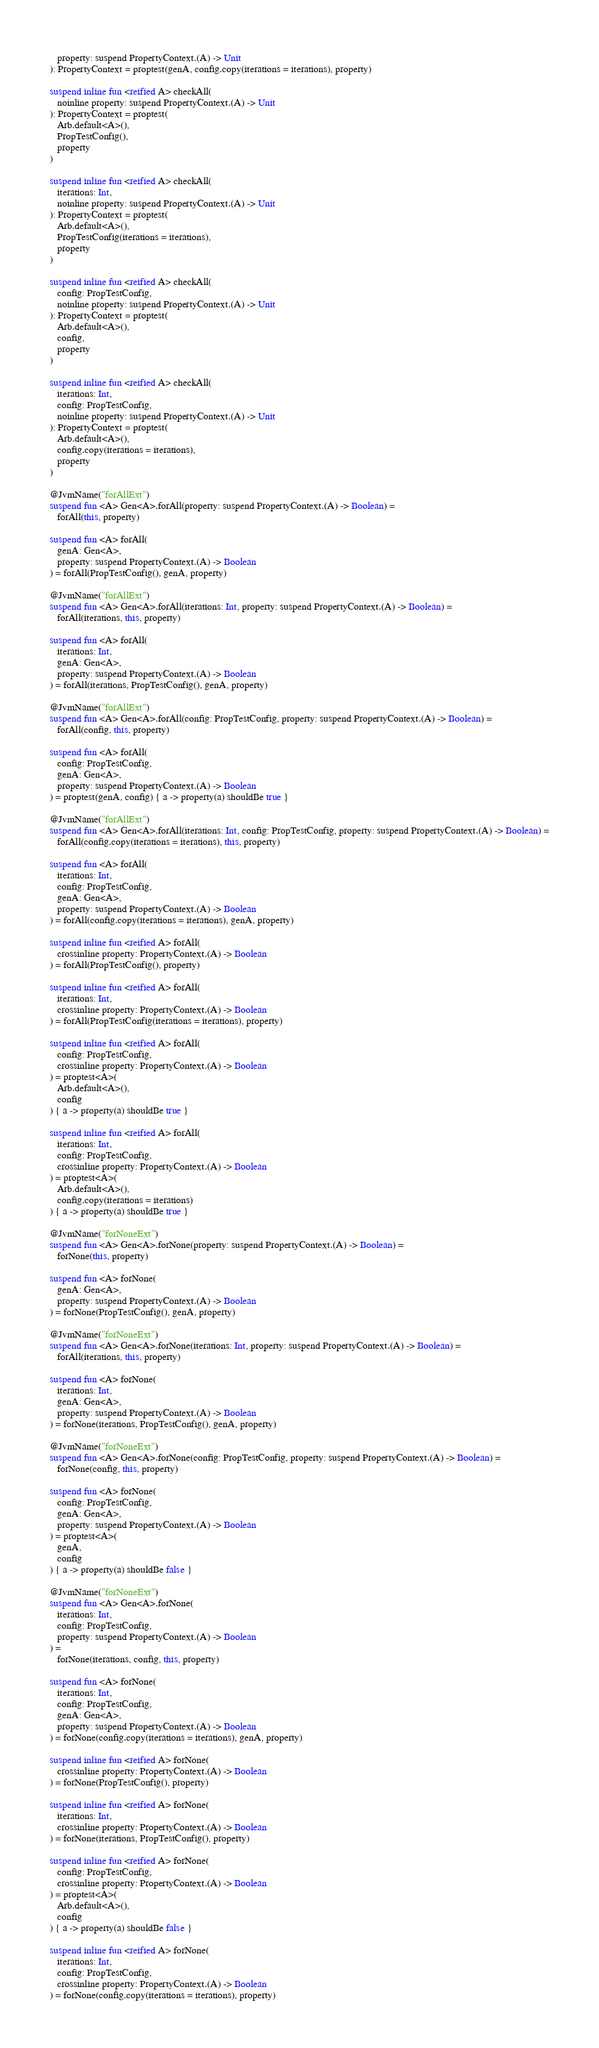<code> <loc_0><loc_0><loc_500><loc_500><_Kotlin_>   property: suspend PropertyContext.(A) -> Unit
): PropertyContext = proptest(genA, config.copy(iterations = iterations), property)

suspend inline fun <reified A> checkAll(
   noinline property: suspend PropertyContext.(A) -> Unit
): PropertyContext = proptest(
   Arb.default<A>(),
   PropTestConfig(),
   property
)

suspend inline fun <reified A> checkAll(
   iterations: Int,
   noinline property: suspend PropertyContext.(A) -> Unit
): PropertyContext = proptest(
   Arb.default<A>(),
   PropTestConfig(iterations = iterations),
   property
)

suspend inline fun <reified A> checkAll(
   config: PropTestConfig,
   noinline property: suspend PropertyContext.(A) -> Unit
): PropertyContext = proptest(
   Arb.default<A>(),
   config,
   property
)

suspend inline fun <reified A> checkAll(
   iterations: Int,
   config: PropTestConfig,
   noinline property: suspend PropertyContext.(A) -> Unit
): PropertyContext = proptest(
   Arb.default<A>(),
   config.copy(iterations = iterations),
   property
)

@JvmName("forAllExt")
suspend fun <A> Gen<A>.forAll(property: suspend PropertyContext.(A) -> Boolean) =
   forAll(this, property)

suspend fun <A> forAll(
   genA: Gen<A>,
   property: suspend PropertyContext.(A) -> Boolean
) = forAll(PropTestConfig(), genA, property)

@JvmName("forAllExt")
suspend fun <A> Gen<A>.forAll(iterations: Int, property: suspend PropertyContext.(A) -> Boolean) =
   forAll(iterations, this, property)

suspend fun <A> forAll(
   iterations: Int,
   genA: Gen<A>,
   property: suspend PropertyContext.(A) -> Boolean
) = forAll(iterations, PropTestConfig(), genA, property)

@JvmName("forAllExt")
suspend fun <A> Gen<A>.forAll(config: PropTestConfig, property: suspend PropertyContext.(A) -> Boolean) =
   forAll(config, this, property)

suspend fun <A> forAll(
   config: PropTestConfig,
   genA: Gen<A>,
   property: suspend PropertyContext.(A) -> Boolean
) = proptest(genA, config) { a -> property(a) shouldBe true }

@JvmName("forAllExt")
suspend fun <A> Gen<A>.forAll(iterations: Int, config: PropTestConfig, property: suspend PropertyContext.(A) -> Boolean) =
   forAll(config.copy(iterations = iterations), this, property)

suspend fun <A> forAll(
   iterations: Int,
   config: PropTestConfig,
   genA: Gen<A>,
   property: suspend PropertyContext.(A) -> Boolean
) = forAll(config.copy(iterations = iterations), genA, property)

suspend inline fun <reified A> forAll(
   crossinline property: PropertyContext.(A) -> Boolean
) = forAll(PropTestConfig(), property)

suspend inline fun <reified A> forAll(
   iterations: Int,
   crossinline property: PropertyContext.(A) -> Boolean
) = forAll(PropTestConfig(iterations = iterations), property)

suspend inline fun <reified A> forAll(
   config: PropTestConfig,
   crossinline property: PropertyContext.(A) -> Boolean
) = proptest<A>(
   Arb.default<A>(),
   config
) { a -> property(a) shouldBe true }

suspend inline fun <reified A> forAll(
   iterations: Int,
   config: PropTestConfig,
   crossinline property: PropertyContext.(A) -> Boolean
) = proptest<A>(
   Arb.default<A>(),
   config.copy(iterations = iterations)
) { a -> property(a) shouldBe true }

@JvmName("forNoneExt")
suspend fun <A> Gen<A>.forNone(property: suspend PropertyContext.(A) -> Boolean) =
   forNone(this, property)

suspend fun <A> forNone(
   genA: Gen<A>,
   property: suspend PropertyContext.(A) -> Boolean
) = forNone(PropTestConfig(), genA, property)

@JvmName("forNoneExt")
suspend fun <A> Gen<A>.forNone(iterations: Int, property: suspend PropertyContext.(A) -> Boolean) =
   forAll(iterations, this, property)

suspend fun <A> forNone(
   iterations: Int,
   genA: Gen<A>,
   property: suspend PropertyContext.(A) -> Boolean
) = forNone(iterations, PropTestConfig(), genA, property)

@JvmName("forNoneExt")
suspend fun <A> Gen<A>.forNone(config: PropTestConfig, property: suspend PropertyContext.(A) -> Boolean) =
   forNone(config, this, property)

suspend fun <A> forNone(
   config: PropTestConfig,
   genA: Gen<A>,
   property: suspend PropertyContext.(A) -> Boolean
) = proptest<A>(
   genA,
   config
) { a -> property(a) shouldBe false }

@JvmName("forNoneExt")
suspend fun <A> Gen<A>.forNone(
   iterations: Int,
   config: PropTestConfig,
   property: suspend PropertyContext.(A) -> Boolean
) =
   forNone(iterations, config, this, property)

suspend fun <A> forNone(
   iterations: Int,
   config: PropTestConfig,
   genA: Gen<A>,
   property: suspend PropertyContext.(A) -> Boolean
) = forNone(config.copy(iterations = iterations), genA, property)

suspend inline fun <reified A> forNone(
   crossinline property: PropertyContext.(A) -> Boolean
) = forNone(PropTestConfig(), property)

suspend inline fun <reified A> forNone(
   iterations: Int,
   crossinline property: PropertyContext.(A) -> Boolean
) = forNone(iterations, PropTestConfig(), property)

suspend inline fun <reified A> forNone(
   config: PropTestConfig,
   crossinline property: PropertyContext.(A) -> Boolean
) = proptest<A>(
   Arb.default<A>(),
   config
) { a -> property(a) shouldBe false }

suspend inline fun <reified A> forNone(
   iterations: Int,
   config: PropTestConfig,
   crossinline property: PropertyContext.(A) -> Boolean
) = forNone(config.copy(iterations = iterations), property)
</code> 